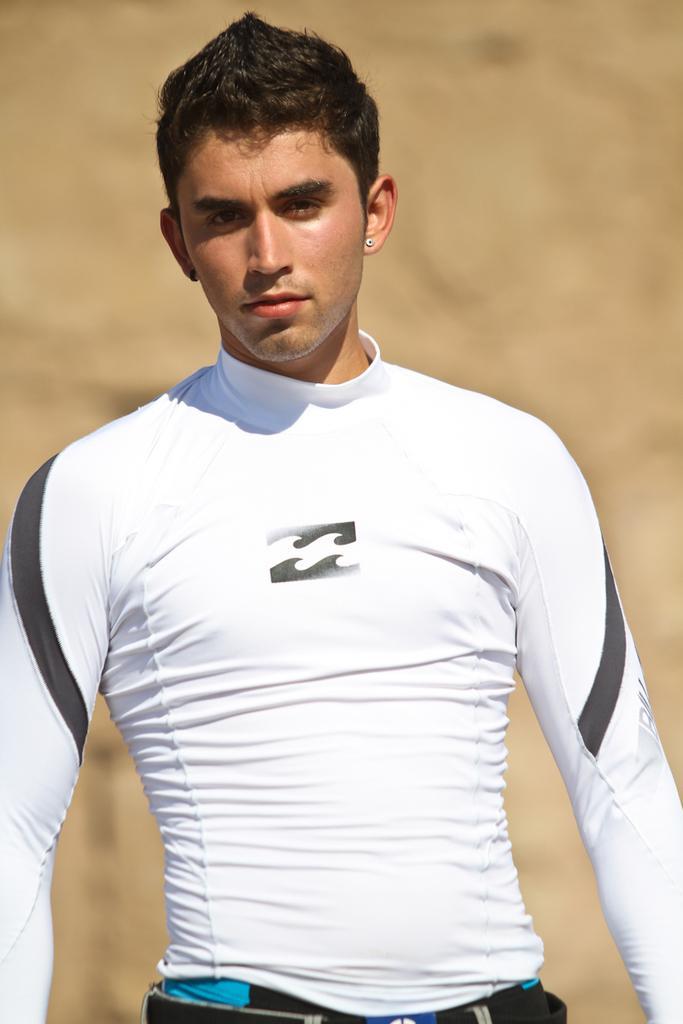Could you give a brief overview of what you see in this image? In this image we can see a person wearing white and black color T-shirt standing. 